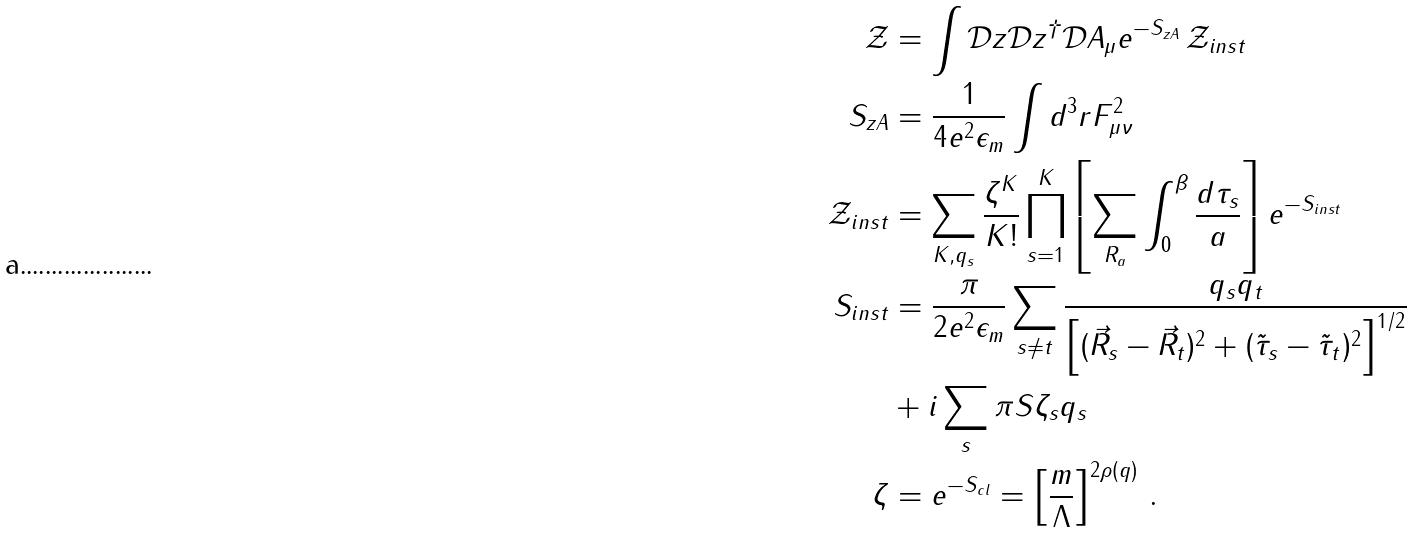<formula> <loc_0><loc_0><loc_500><loc_500>\mathcal { Z } & = \int \mathcal { D } z \mathcal { D } z ^ { \dagger } \mathcal { D } A _ { \mu } e ^ { - S _ { z A } } \, \mathcal { Z } _ { i n s t } \\ S _ { z A } & = \frac { 1 } { 4 e ^ { 2 } \epsilon _ { m } } \int d ^ { 3 } r F _ { \mu \nu } ^ { 2 } \\ \mathcal { Z } _ { i n s t } & = \sum _ { K , q _ { s } } \frac { \zeta ^ { K } } { K ! } \prod _ { s = 1 } ^ { K } \left [ \sum _ { R _ { a } } \int _ { 0 } ^ { \beta } \frac { d \tau _ { s } } { a } \right ] e ^ { - S _ { i n s t } } \\ S _ { i n s t } & = \frac { \pi } { 2 e ^ { 2 } \epsilon _ { m } } \sum _ { s \neq t } \frac { q _ { s } q _ { t } } { \left [ ( \vec { R } _ { s } - \vec { R } _ { t } ) ^ { 2 } + ( \tilde { \tau } _ { s } - \tilde { \tau } _ { t } ) ^ { 2 } \right ] ^ { 1 / 2 } } \\ & + i \sum _ { s } \pi S \zeta _ { s } q _ { s } \\ \zeta & = e ^ { - S _ { c l } } = \left [ \frac { m } { \Lambda } \right ] ^ { 2 \rho ( q ) } \, .</formula> 